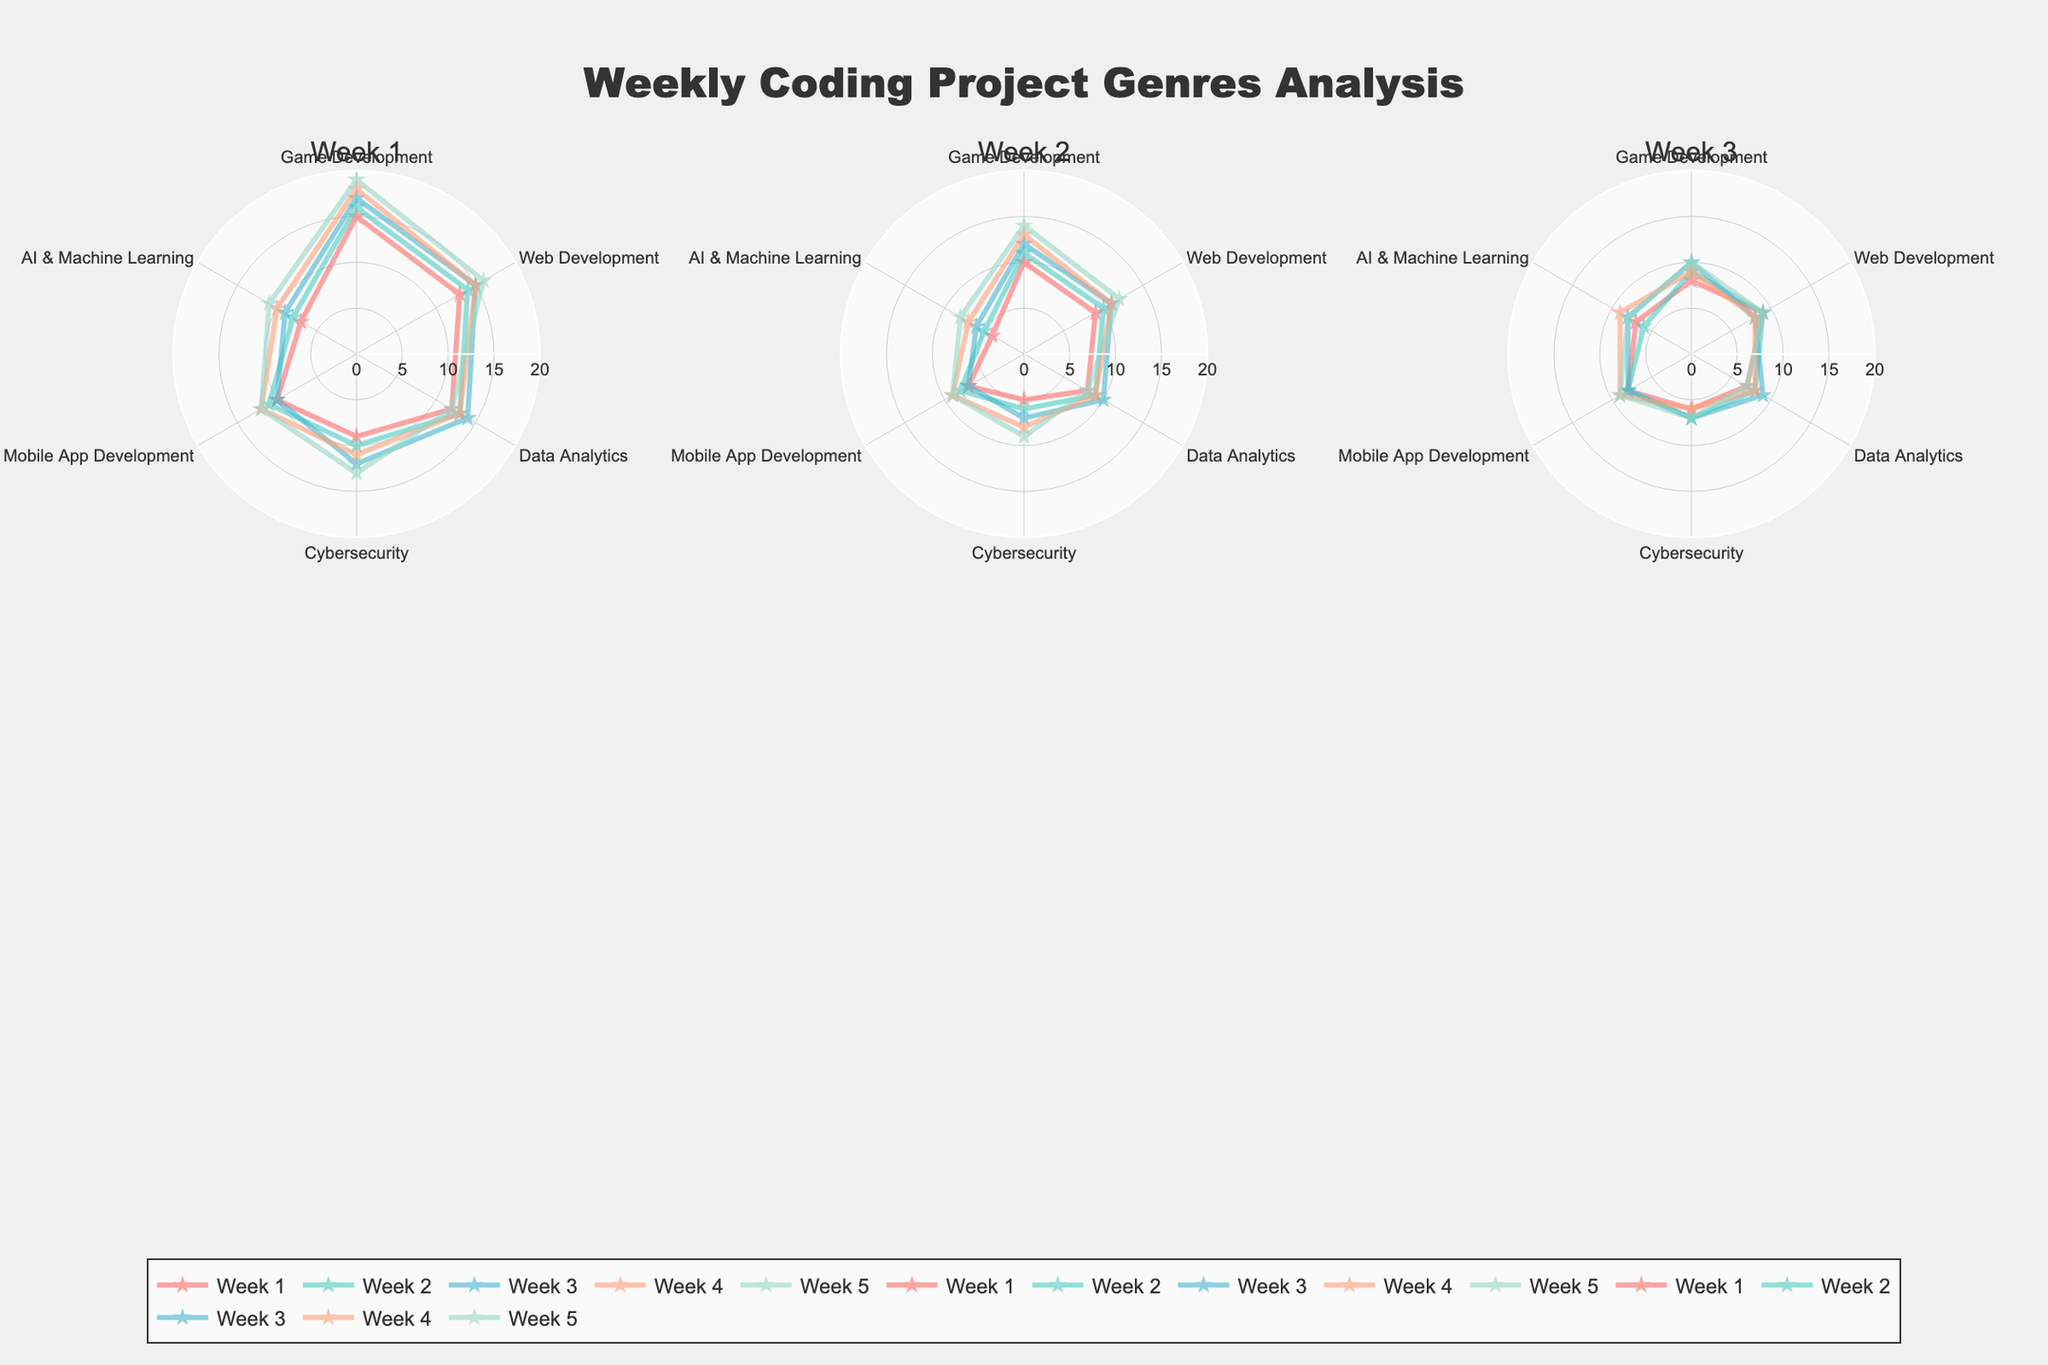What is the title of the figure? The title of the figure is usually shown prominently at the top of the plot, indicating what it represents. By looking at the figure, you can see that the title is "Weekly Coding Project Genres Analysis".
Answer: "Weekly Coding Project Genres Analysis" Which week had the highest attendance for Game Development? In the subplot for each week, the data points for Game Development can be examined. Week 5 shows the highest attendance for Game Development at 19.
Answer: Week 5 How many categories are being analyzed in the figure? The radar chart has different axes, each representing a project genre. By counting the project genres in one subplot, we can see that there are 6 categories: Game Development, Web Development, Data Analytics, Cybersecurity, Mobile App Development, AI & Machine Learning.
Answer: 6 What is the student satisfaction for Web Development in Week 3? In the subplot for Week 3, locate the data points for Web Development and check the value for Student Satisfaction. The value is 8.
Answer: 8 Which category has the lowest student completion in Week 2? In the subplot for Week 2, compare the student completion values for each category. AI & Machine Learning has the lowest student completion at 5.
Answer: AI & Machine Learning What is the average attendance across all weeks for Cybersecurity? To find the average, sum the attendance of Cybersecurity over all weeks (9 + 10 + 12 + 11 + 13) which equals 55, and then divide by 5. The average is 55/5 = 11.
Answer: 11 Compare the student satisfaction for Mobile App Development in Week 1 and Week 5. Which week has higher satisfaction? By examining the subplots for Week 1 and Week 5, observe the student satisfaction values for Mobile App Development. Week 5 has a student satisfaction of 9 whereas Week 1 has a satisfaction of 8. Therefore, Week 5 has higher satisfaction.
Answer: Week 5 Which week shows the highest overall student completion for all categories combined? Sum the student completion values for each category in all weeks and compare. For Week 1: 43, Week 2: 49, Week 3: 53, Week 4: 57, Week 5: 60 (10+9+8+5+7+4, 11+10+9+6+8+5, 12+11+10+7+7+6, 13+11+9+8+9+7, 14+12+8+9+9+8). Week 5 shows the highest overall student completion at 60.
Answer: Week 5 